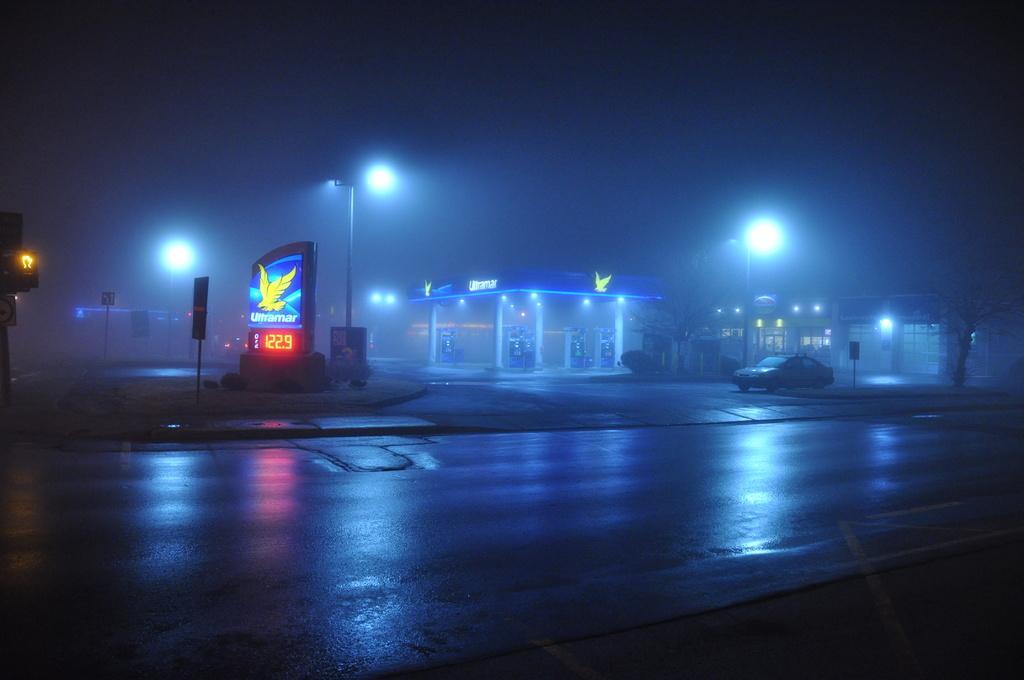Could you give a brief overview of what you see in this image? In this image we can see one building, some lights attached to the building, some different objects are on the surface, some street lights with poles, some poles with boards, on fence, one traffic signal pole, two roads, one car parked in front of the building, one board attached to the fence, some trees, bushes and grass on the surface. There is one big board with text, image and time. 